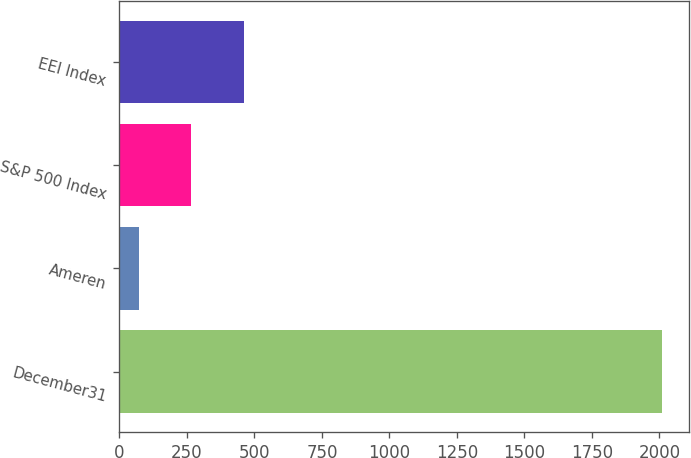Convert chart. <chart><loc_0><loc_0><loc_500><loc_500><bar_chart><fcel>December31<fcel>Ameren<fcel>S&P 500 Index<fcel>EEI Index<nl><fcel>2009<fcel>73.08<fcel>266.67<fcel>460.26<nl></chart> 